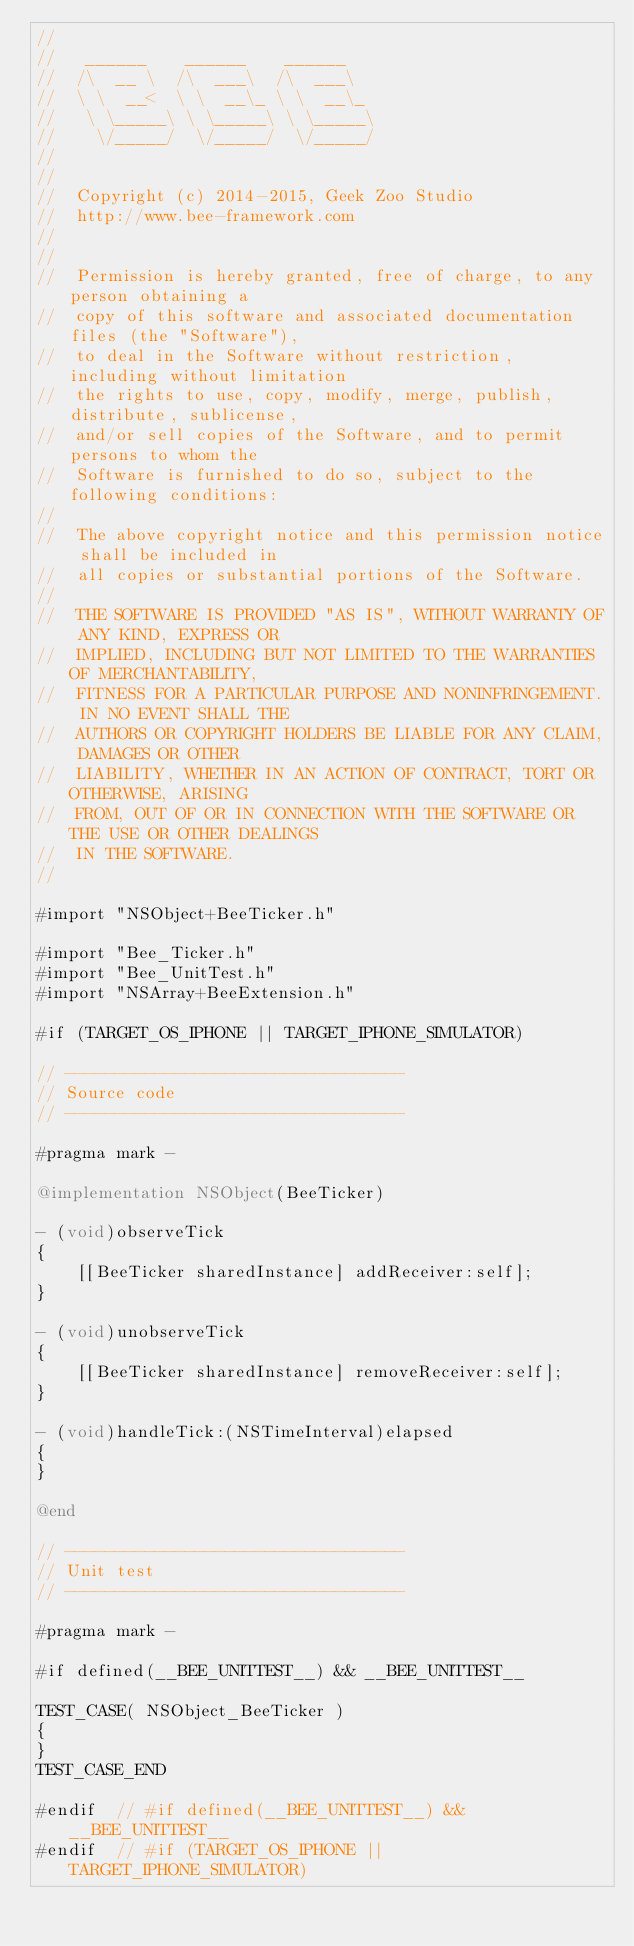<code> <loc_0><loc_0><loc_500><loc_500><_ObjectiveC_>//
//	 ______    ______    ______
//	/\  __ \  /\  ___\  /\  ___\
//	\ \  __<  \ \  __\_ \ \  __\_
//	 \ \_____\ \ \_____\ \ \_____\
//	  \/_____/  \/_____/  \/_____/
//
//
//	Copyright (c) 2014-2015, Geek Zoo Studio
//	http://www.bee-framework.com
//
//
//	Permission is hereby granted, free of charge, to any person obtaining a
//	copy of this software and associated documentation files (the "Software"),
//	to deal in the Software without restriction, including without limitation
//	the rights to use, copy, modify, merge, publish, distribute, sublicense,
//	and/or sell copies of the Software, and to permit persons to whom the
//	Software is furnished to do so, subject to the following conditions:
//
//	The above copyright notice and this permission notice shall be included in
//	all copies or substantial portions of the Software.
//
//	THE SOFTWARE IS PROVIDED "AS IS", WITHOUT WARRANTY OF ANY KIND, EXPRESS OR
//	IMPLIED, INCLUDING BUT NOT LIMITED TO THE WARRANTIES OF MERCHANTABILITY,
//	FITNESS FOR A PARTICULAR PURPOSE AND NONINFRINGEMENT. IN NO EVENT SHALL THE
//	AUTHORS OR COPYRIGHT HOLDERS BE LIABLE FOR ANY CLAIM, DAMAGES OR OTHER
//	LIABILITY, WHETHER IN AN ACTION OF CONTRACT, TORT OR OTHERWISE, ARISING
//	FROM, OUT OF OR IN CONNECTION WITH THE SOFTWARE OR THE USE OR OTHER DEALINGS
//	IN THE SOFTWARE.
//

#import "NSObject+BeeTicker.h"

#import "Bee_Ticker.h"
#import "Bee_UnitTest.h"
#import "NSArray+BeeExtension.h"

#if (TARGET_OS_IPHONE || TARGET_IPHONE_SIMULATOR)

// ----------------------------------
// Source code
// ----------------------------------

#pragma mark -

@implementation NSObject(BeeTicker)

- (void)observeTick
{
	[[BeeTicker sharedInstance] addReceiver:self];
}

- (void)unobserveTick
{
	[[BeeTicker sharedInstance] removeReceiver:self];
}

- (void)handleTick:(NSTimeInterval)elapsed
{
}

@end

// ----------------------------------
// Unit test
// ----------------------------------

#pragma mark -

#if defined(__BEE_UNITTEST__) && __BEE_UNITTEST__

TEST_CASE( NSObject_BeeTicker )
{
}
TEST_CASE_END

#endif	// #if defined(__BEE_UNITTEST__) && __BEE_UNITTEST__
#endif	// #if (TARGET_OS_IPHONE || TARGET_IPHONE_SIMULATOR)
</code> 